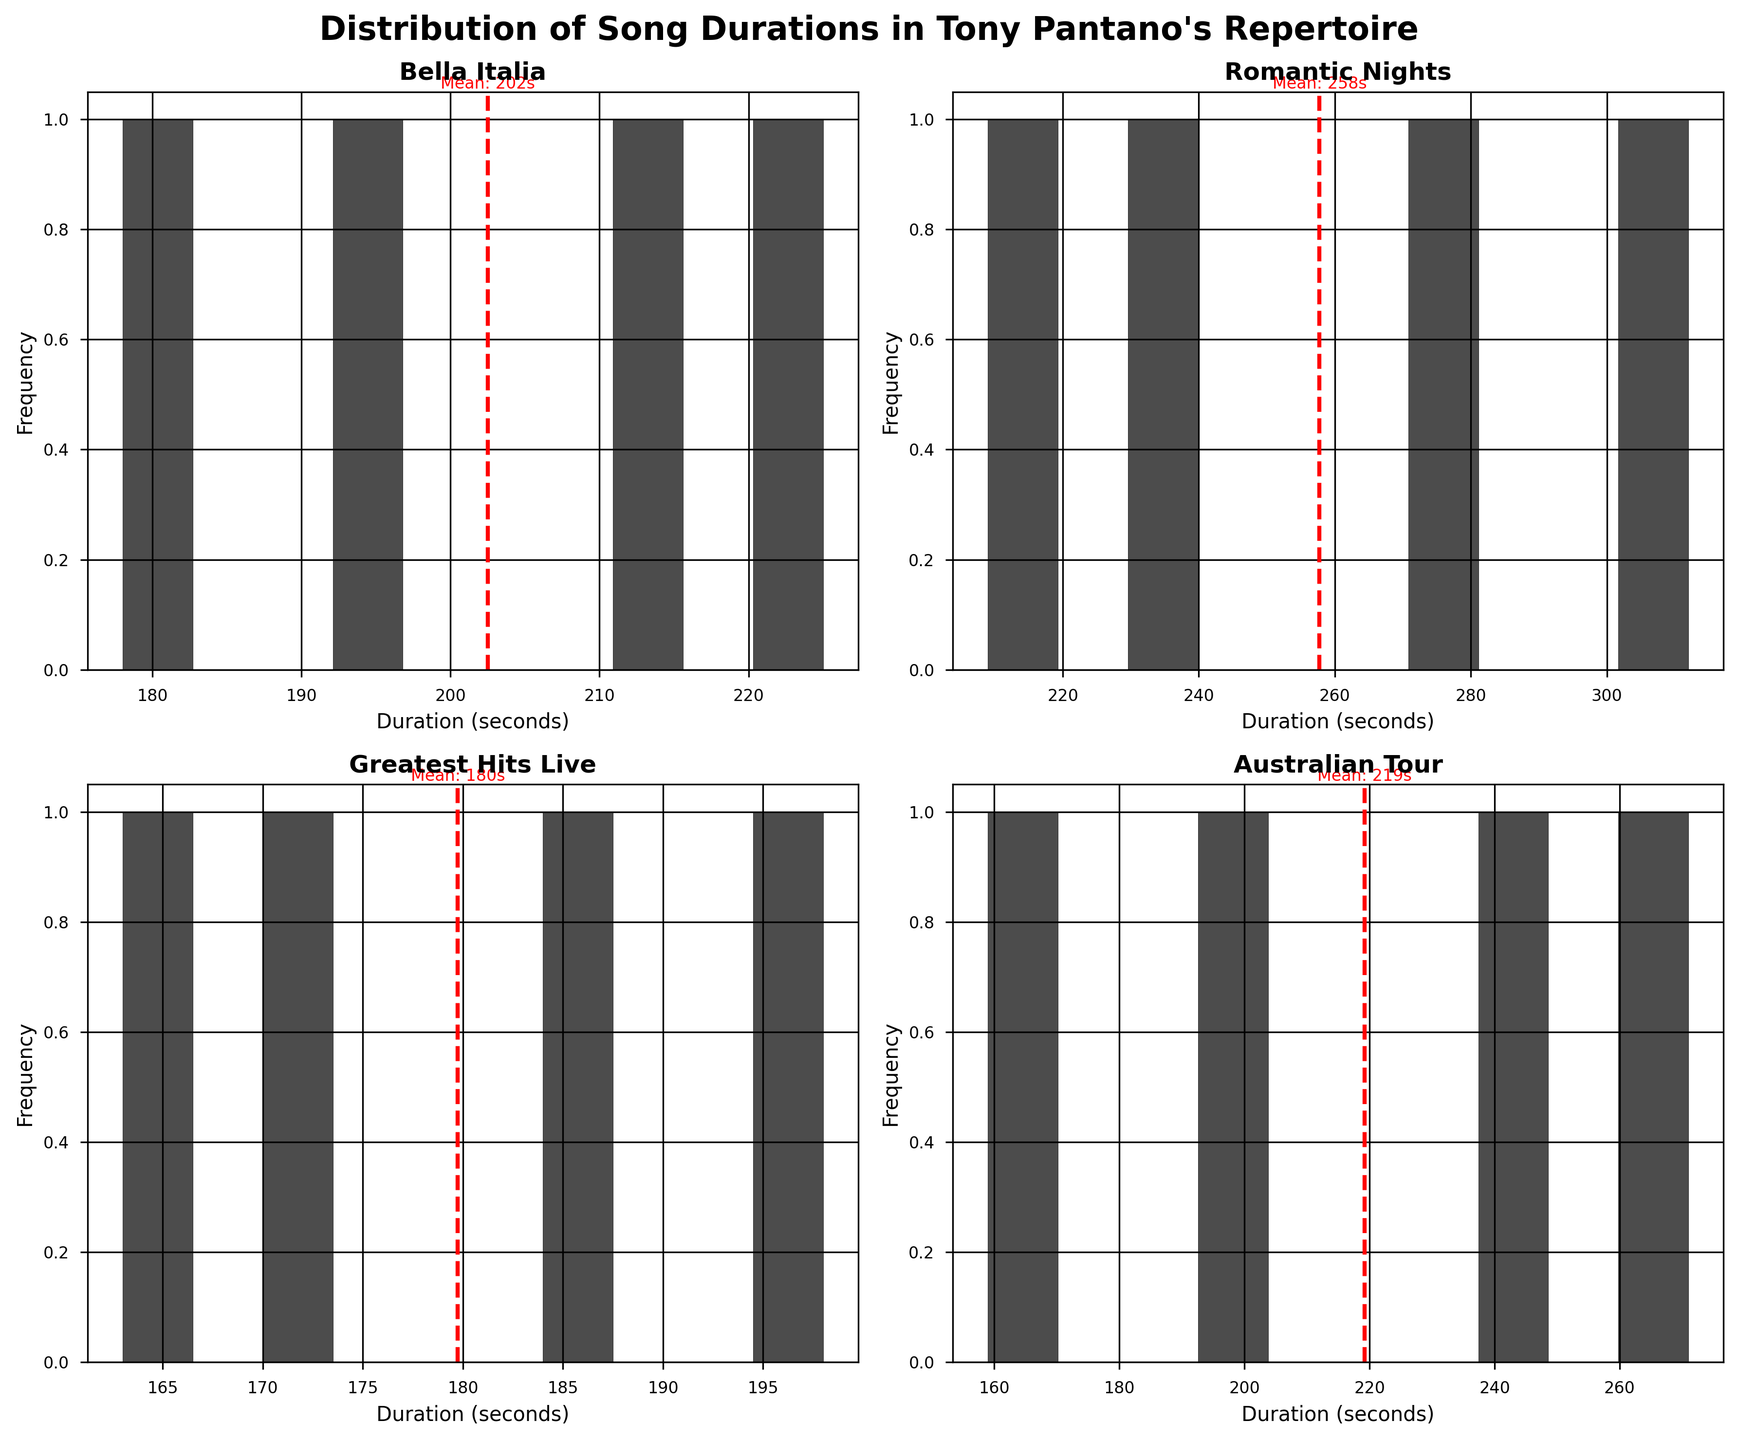What is the title of the figure? The title of the figure is positioned at the top and is generally a short description summarizing the content of the plot.
Answer: Distribution of Song Durations in Tony Pantano's Repertoire How many subplots are there in the figure? Each album has its data plotted in a separate histogram, and there are four unique albums indicated in the data, one in each subplot.
Answer: 4 Which album has the song with the longest duration? The longest duration song will be seen in the histogram extending to the rightmost edge. Here, "Romantic Nights" has the longest song duration with a bar extending close to 312 seconds (5:12).
Answer: Romantic Nights What is the mean song duration for "Greatest Hits Live"? To find the mean, look for the red dashed line in the subplot titled "Greatest Hits Live". The text associated with this line indicates the mean duration.
Answer: About 182 seconds What's the range of song durations for the "Bella Italia" album? The range can be determined by looking at the horizontal axis of the "Bella Italia" subplot and noting the lowest and highest values where there are bars. Here, it spans from around 170 seconds to 225 seconds.
Answer: Approximately 170-225 seconds How many songs in "Australian Tour" album are shorter than 180 seconds? By counting the bars to the left of the 180-second mark in the histogram for "Australian Tour", one can determine how many songs fall below this duration. The histogram for "Australian Tour" shows only one bar is before the 180-second mark indicating one song.
Answer: 1 song Which album has the most varied (widest range) song durations? The most varied album will have a histogram with bars spread out over the widest range of the horizontal axis. By comparing the subplots, "Romantic Nights" shows the widest spread from around 180 to 320 seconds.
Answer: Romantic Nights Is the mean duration of songs higher for "Australian Tour" or "Bella Italia"? Compare the positions of the red dashed lines in the corresponding subplots. The "Australian Tour" red dashed line is at approximately 240 seconds while "Bella Italia" is lower around 200 seconds.
Answer: Australian Tour Which album has the most songs with durations close to the mean? Look for the histogram with the highest central concentration of bars around the red dashed line (mean). The subplot for "Bella Italia" appears the most clustered around its mean.
Answer: Bella Italia Is there an album where all songs are shorter than 4 minutes? (1 minute = 60 seconds) For all songs to be shorter than 4 minutes, their durations should be less than 240 seconds. Checking the histograms, "Greatest Hits Live" shows all song durations under this threshold.
Answer: Greatest Hits Live 